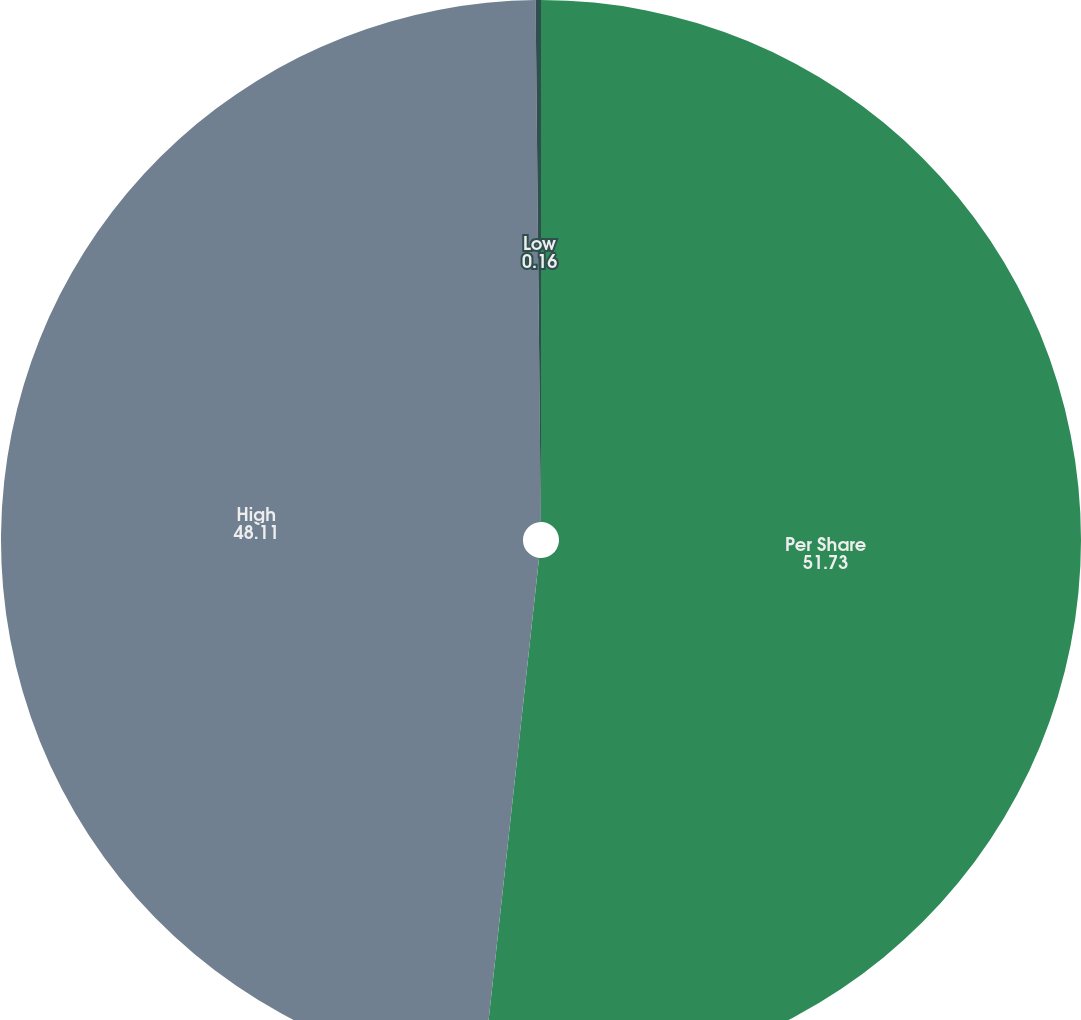<chart> <loc_0><loc_0><loc_500><loc_500><pie_chart><fcel>Per Share<fcel>High<fcel>Low<nl><fcel>51.73%<fcel>48.11%<fcel>0.16%<nl></chart> 